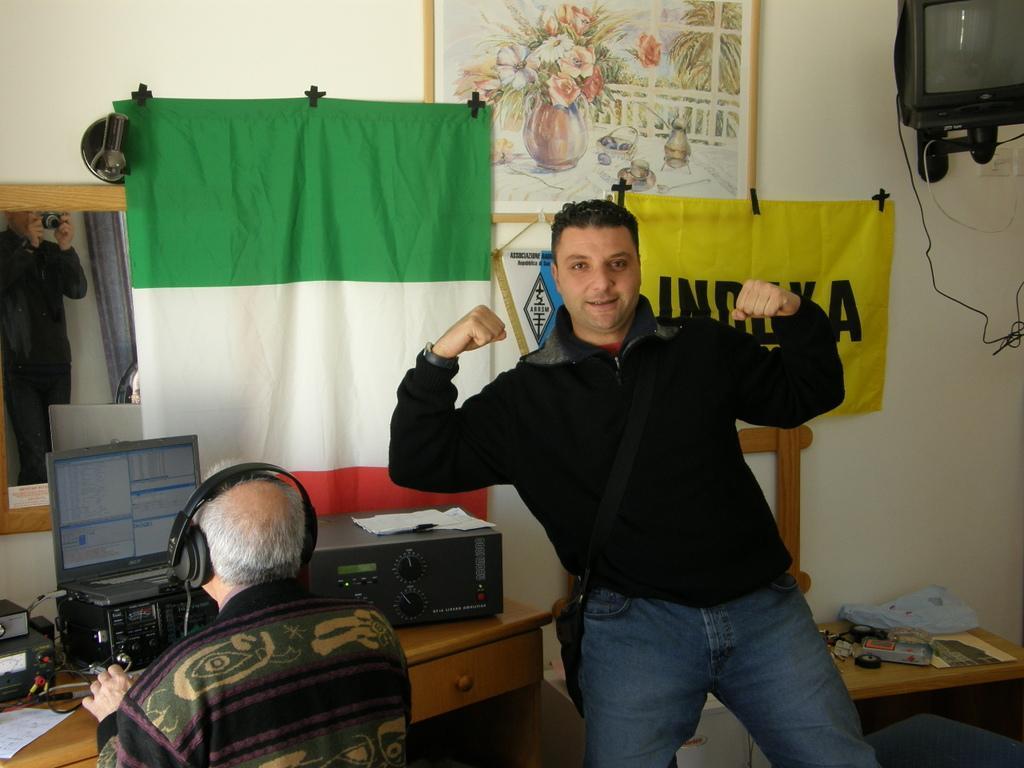Could you give a brief overview of what you see in this image? Picture, mirror, flag, banner and television is on the wall. On these tables there is a laptop, plastic cover, papers, devices and things. This man is sitting on a chair and wired headset. This man is standing and wire bag. In this mirror there is a reflection of a person holding a camera. 